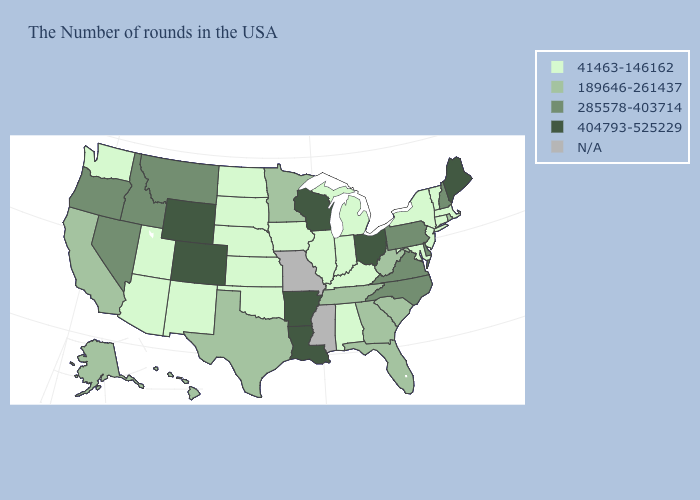Name the states that have a value in the range 41463-146162?
Answer briefly. Massachusetts, Vermont, Connecticut, New York, New Jersey, Maryland, Michigan, Kentucky, Indiana, Alabama, Illinois, Iowa, Kansas, Nebraska, Oklahoma, South Dakota, North Dakota, New Mexico, Utah, Arizona, Washington. Name the states that have a value in the range 189646-261437?
Write a very short answer. Rhode Island, South Carolina, West Virginia, Florida, Georgia, Tennessee, Minnesota, Texas, California, Alaska, Hawaii. Name the states that have a value in the range 189646-261437?
Keep it brief. Rhode Island, South Carolina, West Virginia, Florida, Georgia, Tennessee, Minnesota, Texas, California, Alaska, Hawaii. What is the highest value in states that border Texas?
Write a very short answer. 404793-525229. Name the states that have a value in the range 404793-525229?
Short answer required. Maine, Ohio, Wisconsin, Louisiana, Arkansas, Wyoming, Colorado. Name the states that have a value in the range 285578-403714?
Write a very short answer. New Hampshire, Delaware, Pennsylvania, Virginia, North Carolina, Montana, Idaho, Nevada, Oregon. Name the states that have a value in the range 189646-261437?
Quick response, please. Rhode Island, South Carolina, West Virginia, Florida, Georgia, Tennessee, Minnesota, Texas, California, Alaska, Hawaii. Which states have the highest value in the USA?
Write a very short answer. Maine, Ohio, Wisconsin, Louisiana, Arkansas, Wyoming, Colorado. What is the value of Florida?
Concise answer only. 189646-261437. Name the states that have a value in the range 189646-261437?
Be succinct. Rhode Island, South Carolina, West Virginia, Florida, Georgia, Tennessee, Minnesota, Texas, California, Alaska, Hawaii. What is the highest value in the Northeast ?
Short answer required. 404793-525229. Among the states that border Florida , which have the lowest value?
Give a very brief answer. Alabama. Which states hav the highest value in the MidWest?
Be succinct. Ohio, Wisconsin. Name the states that have a value in the range 404793-525229?
Be succinct. Maine, Ohio, Wisconsin, Louisiana, Arkansas, Wyoming, Colorado. 